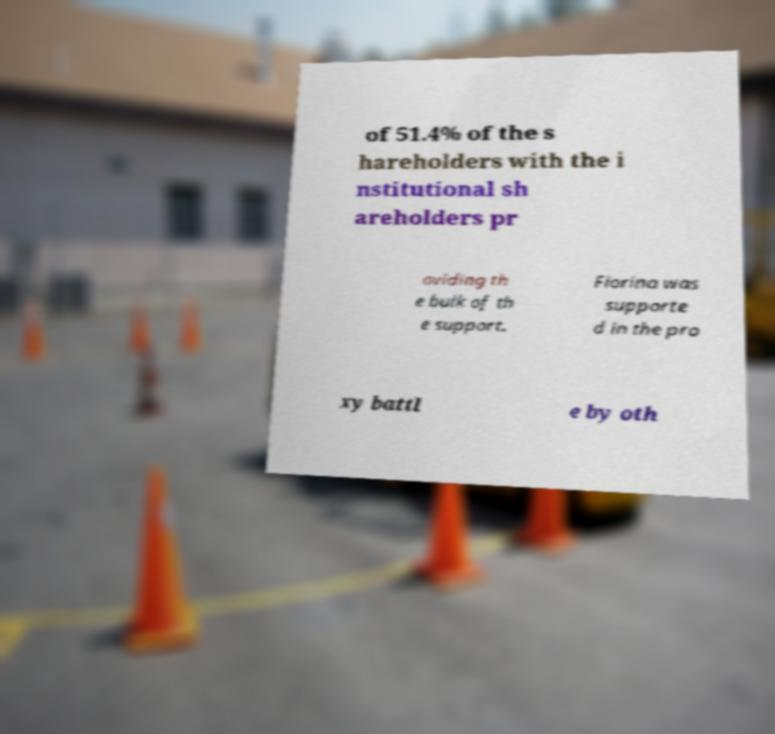Please read and relay the text visible in this image. What does it say? of 51.4% of the s hareholders with the i nstitutional sh areholders pr oviding th e bulk of th e support. Fiorina was supporte d in the pro xy battl e by oth 